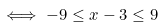Convert formula to latex. <formula><loc_0><loc_0><loc_500><loc_500>\iff - 9 \leq x - 3 \leq 9</formula> 